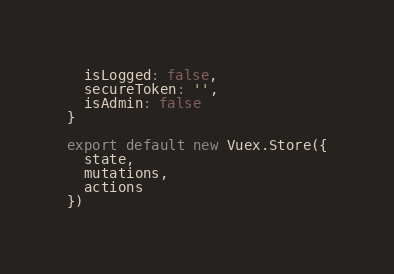<code> <loc_0><loc_0><loc_500><loc_500><_JavaScript_>  isLogged: false,
  secureToken: '',
  isAdmin: false
}

export default new Vuex.Store({
  state,
  mutations,
  actions
})
</code> 